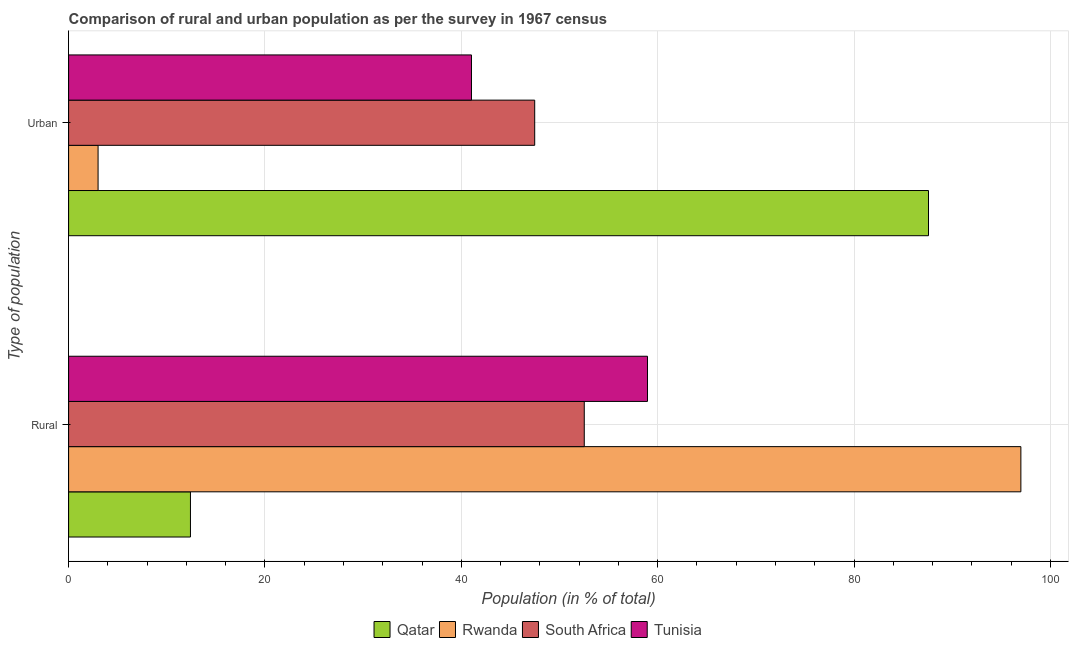How many groups of bars are there?
Keep it short and to the point. 2. Are the number of bars per tick equal to the number of legend labels?
Ensure brevity in your answer.  Yes. Are the number of bars on each tick of the Y-axis equal?
Provide a short and direct response. Yes. How many bars are there on the 2nd tick from the top?
Your answer should be very brief. 4. What is the label of the 2nd group of bars from the top?
Offer a very short reply. Rural. What is the urban population in Rwanda?
Give a very brief answer. 3. Across all countries, what is the maximum rural population?
Your response must be concise. 97. Across all countries, what is the minimum rural population?
Make the answer very short. 12.41. In which country was the rural population maximum?
Make the answer very short. Rwanda. In which country was the urban population minimum?
Provide a succinct answer. Rwanda. What is the total rural population in the graph?
Ensure brevity in your answer.  220.9. What is the difference between the urban population in South Africa and that in Tunisia?
Your response must be concise. 6.44. What is the difference between the rural population in Rwanda and the urban population in South Africa?
Provide a short and direct response. 49.52. What is the average rural population per country?
Keep it short and to the point. 55.22. What is the difference between the rural population and urban population in Rwanda?
Ensure brevity in your answer.  93.99. In how many countries, is the rural population greater than 80 %?
Ensure brevity in your answer.  1. What is the ratio of the rural population in South Africa to that in Qatar?
Give a very brief answer. 4.23. Is the urban population in Tunisia less than that in Qatar?
Your answer should be compact. Yes. In how many countries, is the urban population greater than the average urban population taken over all countries?
Your answer should be very brief. 2. What does the 3rd bar from the top in Urban represents?
Your answer should be compact. Rwanda. What does the 1st bar from the bottom in Urban represents?
Keep it short and to the point. Qatar. How many bars are there?
Offer a terse response. 8. How many countries are there in the graph?
Give a very brief answer. 4. What is the difference between two consecutive major ticks on the X-axis?
Offer a very short reply. 20. Does the graph contain any zero values?
Make the answer very short. No. Where does the legend appear in the graph?
Your answer should be compact. Bottom center. How many legend labels are there?
Provide a short and direct response. 4. How are the legend labels stacked?
Provide a succinct answer. Horizontal. What is the title of the graph?
Offer a very short reply. Comparison of rural and urban population as per the survey in 1967 census. What is the label or title of the X-axis?
Make the answer very short. Population (in % of total). What is the label or title of the Y-axis?
Offer a very short reply. Type of population. What is the Population (in % of total) of Qatar in Rural?
Offer a terse response. 12.41. What is the Population (in % of total) in Rwanda in Rural?
Keep it short and to the point. 97. What is the Population (in % of total) of South Africa in Rural?
Ensure brevity in your answer.  52.52. What is the Population (in % of total) in Tunisia in Rural?
Give a very brief answer. 58.96. What is the Population (in % of total) in Qatar in Urban?
Keep it short and to the point. 87.59. What is the Population (in % of total) in Rwanda in Urban?
Give a very brief answer. 3. What is the Population (in % of total) of South Africa in Urban?
Make the answer very short. 47.48. What is the Population (in % of total) in Tunisia in Urban?
Your answer should be compact. 41.04. Across all Type of population, what is the maximum Population (in % of total) in Qatar?
Give a very brief answer. 87.59. Across all Type of population, what is the maximum Population (in % of total) in Rwanda?
Offer a very short reply. 97. Across all Type of population, what is the maximum Population (in % of total) in South Africa?
Give a very brief answer. 52.52. Across all Type of population, what is the maximum Population (in % of total) of Tunisia?
Offer a terse response. 58.96. Across all Type of population, what is the minimum Population (in % of total) of Qatar?
Provide a succinct answer. 12.41. Across all Type of population, what is the minimum Population (in % of total) in Rwanda?
Keep it short and to the point. 3. Across all Type of population, what is the minimum Population (in % of total) of South Africa?
Keep it short and to the point. 47.48. Across all Type of population, what is the minimum Population (in % of total) in Tunisia?
Offer a very short reply. 41.04. What is the difference between the Population (in % of total) in Qatar in Rural and that in Urban?
Your response must be concise. -75.18. What is the difference between the Population (in % of total) of Rwanda in Rural and that in Urban?
Provide a succinct answer. 93.99. What is the difference between the Population (in % of total) in South Africa in Rural and that in Urban?
Offer a very short reply. 5.05. What is the difference between the Population (in % of total) in Tunisia in Rural and that in Urban?
Your answer should be very brief. 17.93. What is the difference between the Population (in % of total) of Qatar in Rural and the Population (in % of total) of Rwanda in Urban?
Offer a terse response. 9.41. What is the difference between the Population (in % of total) in Qatar in Rural and the Population (in % of total) in South Africa in Urban?
Offer a very short reply. -35.06. What is the difference between the Population (in % of total) of Qatar in Rural and the Population (in % of total) of Tunisia in Urban?
Your answer should be compact. -28.62. What is the difference between the Population (in % of total) of Rwanda in Rural and the Population (in % of total) of South Africa in Urban?
Keep it short and to the point. 49.52. What is the difference between the Population (in % of total) in Rwanda in Rural and the Population (in % of total) in Tunisia in Urban?
Your answer should be very brief. 55.96. What is the difference between the Population (in % of total) of South Africa in Rural and the Population (in % of total) of Tunisia in Urban?
Your answer should be compact. 11.49. What is the average Population (in % of total) in Qatar per Type of population?
Give a very brief answer. 50. What is the average Population (in % of total) in South Africa per Type of population?
Give a very brief answer. 50. What is the average Population (in % of total) in Tunisia per Type of population?
Provide a succinct answer. 50. What is the difference between the Population (in % of total) in Qatar and Population (in % of total) in Rwanda in Rural?
Make the answer very short. -84.58. What is the difference between the Population (in % of total) in Qatar and Population (in % of total) in South Africa in Rural?
Your response must be concise. -40.11. What is the difference between the Population (in % of total) of Qatar and Population (in % of total) of Tunisia in Rural?
Provide a succinct answer. -46.55. What is the difference between the Population (in % of total) of Rwanda and Population (in % of total) of South Africa in Rural?
Offer a terse response. 44.47. What is the difference between the Population (in % of total) of Rwanda and Population (in % of total) of Tunisia in Rural?
Provide a short and direct response. 38.03. What is the difference between the Population (in % of total) in South Africa and Population (in % of total) in Tunisia in Rural?
Offer a terse response. -6.44. What is the difference between the Population (in % of total) of Qatar and Population (in % of total) of Rwanda in Urban?
Your response must be concise. 84.58. What is the difference between the Population (in % of total) in Qatar and Population (in % of total) in South Africa in Urban?
Your response must be concise. 40.11. What is the difference between the Population (in % of total) of Qatar and Population (in % of total) of Tunisia in Urban?
Keep it short and to the point. 46.55. What is the difference between the Population (in % of total) in Rwanda and Population (in % of total) in South Africa in Urban?
Your answer should be very brief. -44.47. What is the difference between the Population (in % of total) in Rwanda and Population (in % of total) in Tunisia in Urban?
Make the answer very short. -38.03. What is the difference between the Population (in % of total) of South Africa and Population (in % of total) of Tunisia in Urban?
Provide a succinct answer. 6.44. What is the ratio of the Population (in % of total) in Qatar in Rural to that in Urban?
Your answer should be very brief. 0.14. What is the ratio of the Population (in % of total) of Rwanda in Rural to that in Urban?
Offer a very short reply. 32.3. What is the ratio of the Population (in % of total) of South Africa in Rural to that in Urban?
Your answer should be compact. 1.11. What is the ratio of the Population (in % of total) in Tunisia in Rural to that in Urban?
Offer a terse response. 1.44. What is the difference between the highest and the second highest Population (in % of total) in Qatar?
Keep it short and to the point. 75.18. What is the difference between the highest and the second highest Population (in % of total) of Rwanda?
Provide a short and direct response. 93.99. What is the difference between the highest and the second highest Population (in % of total) in South Africa?
Your response must be concise. 5.05. What is the difference between the highest and the second highest Population (in % of total) of Tunisia?
Provide a succinct answer. 17.93. What is the difference between the highest and the lowest Population (in % of total) of Qatar?
Give a very brief answer. 75.18. What is the difference between the highest and the lowest Population (in % of total) of Rwanda?
Provide a short and direct response. 93.99. What is the difference between the highest and the lowest Population (in % of total) of South Africa?
Your answer should be very brief. 5.05. What is the difference between the highest and the lowest Population (in % of total) in Tunisia?
Your answer should be compact. 17.93. 